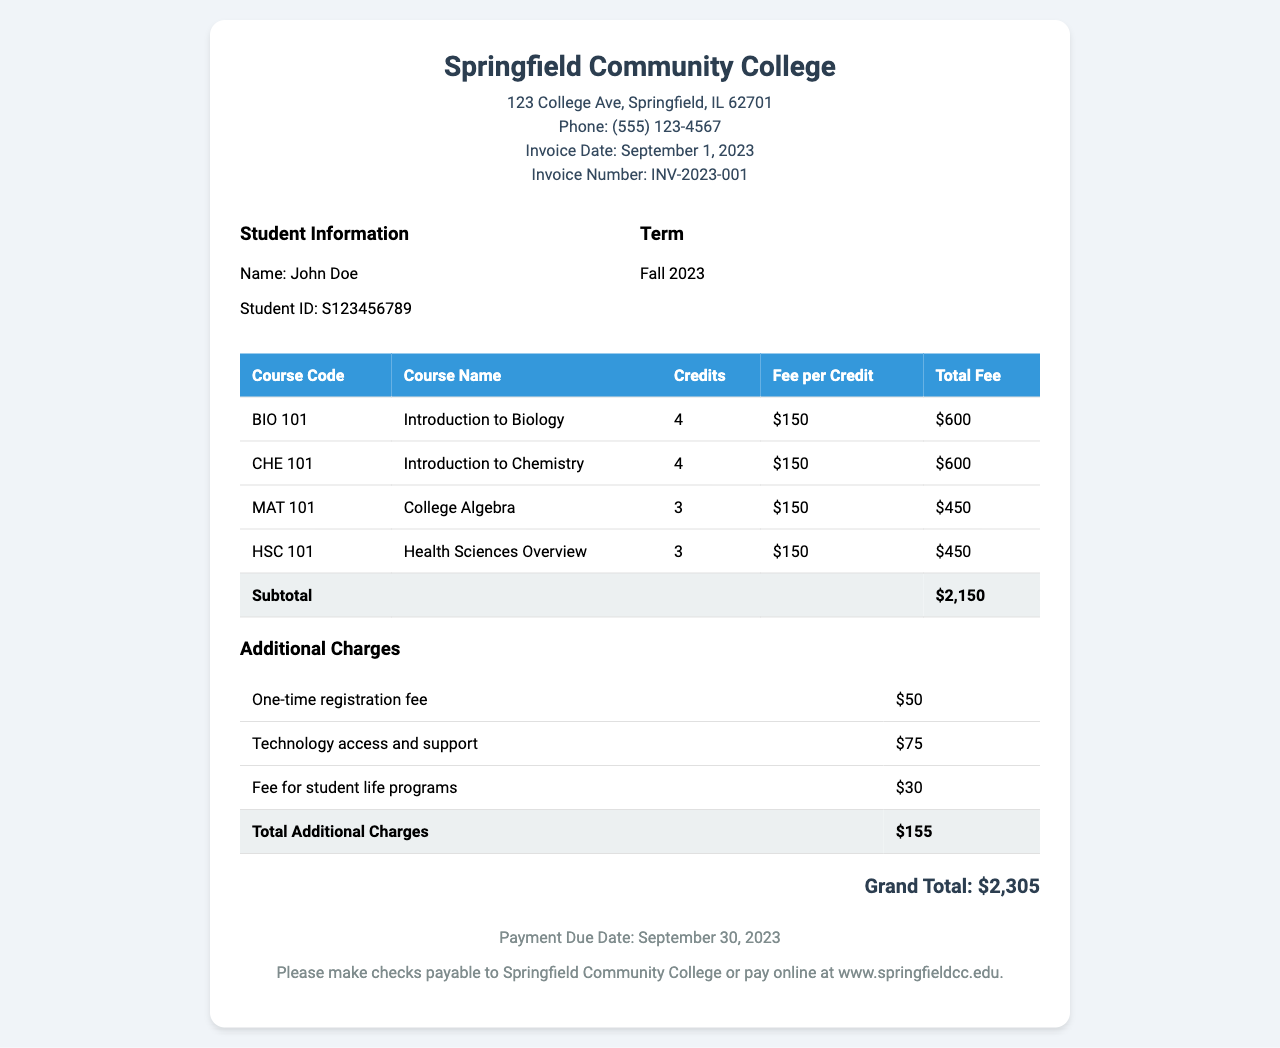What is the invoice number? The invoice number is stated in the header section of the document, labeled as "Invoice Number."
Answer: INV-2023-001 What is the total fee for the course "College Algebra"? The total fee for "College Algebra" is found in the table under the corresponding course, which shows the total fee.
Answer: $450 What is the due date for payment? The payment due date is mentioned in the payment information at the bottom of the document.
Answer: September 30, 2023 How many credits is the "Introduction to Chemistry" course? The number of credits for "Introduction to Chemistry" is specified in the “Credits” column of the course table.
Answer: 4 What is the subtotal amount before additional charges? The subtotal is provided in the table under the "Subtotal" row which sums all course fees prior to additional charges.
Answer: $2,150 What is the total amount of additional charges? The total additional charges are summed in the additional charges section labeled under "Total Additional Charges."
Answer: $155 What is the total amount due? The total amount due is highlighted at the bottom of the invoice as "Grand Total" which includes all fees and charges.
Answer: $2,305 What is the registration fee? The registration fee is listed separately in the additional charges table.
Answer: $50 What is the course code for "Health Sciences Overview"? The course code for "Health Sciences Overview" is given in the course table under the corresponding column.
Answer: HSC 101 